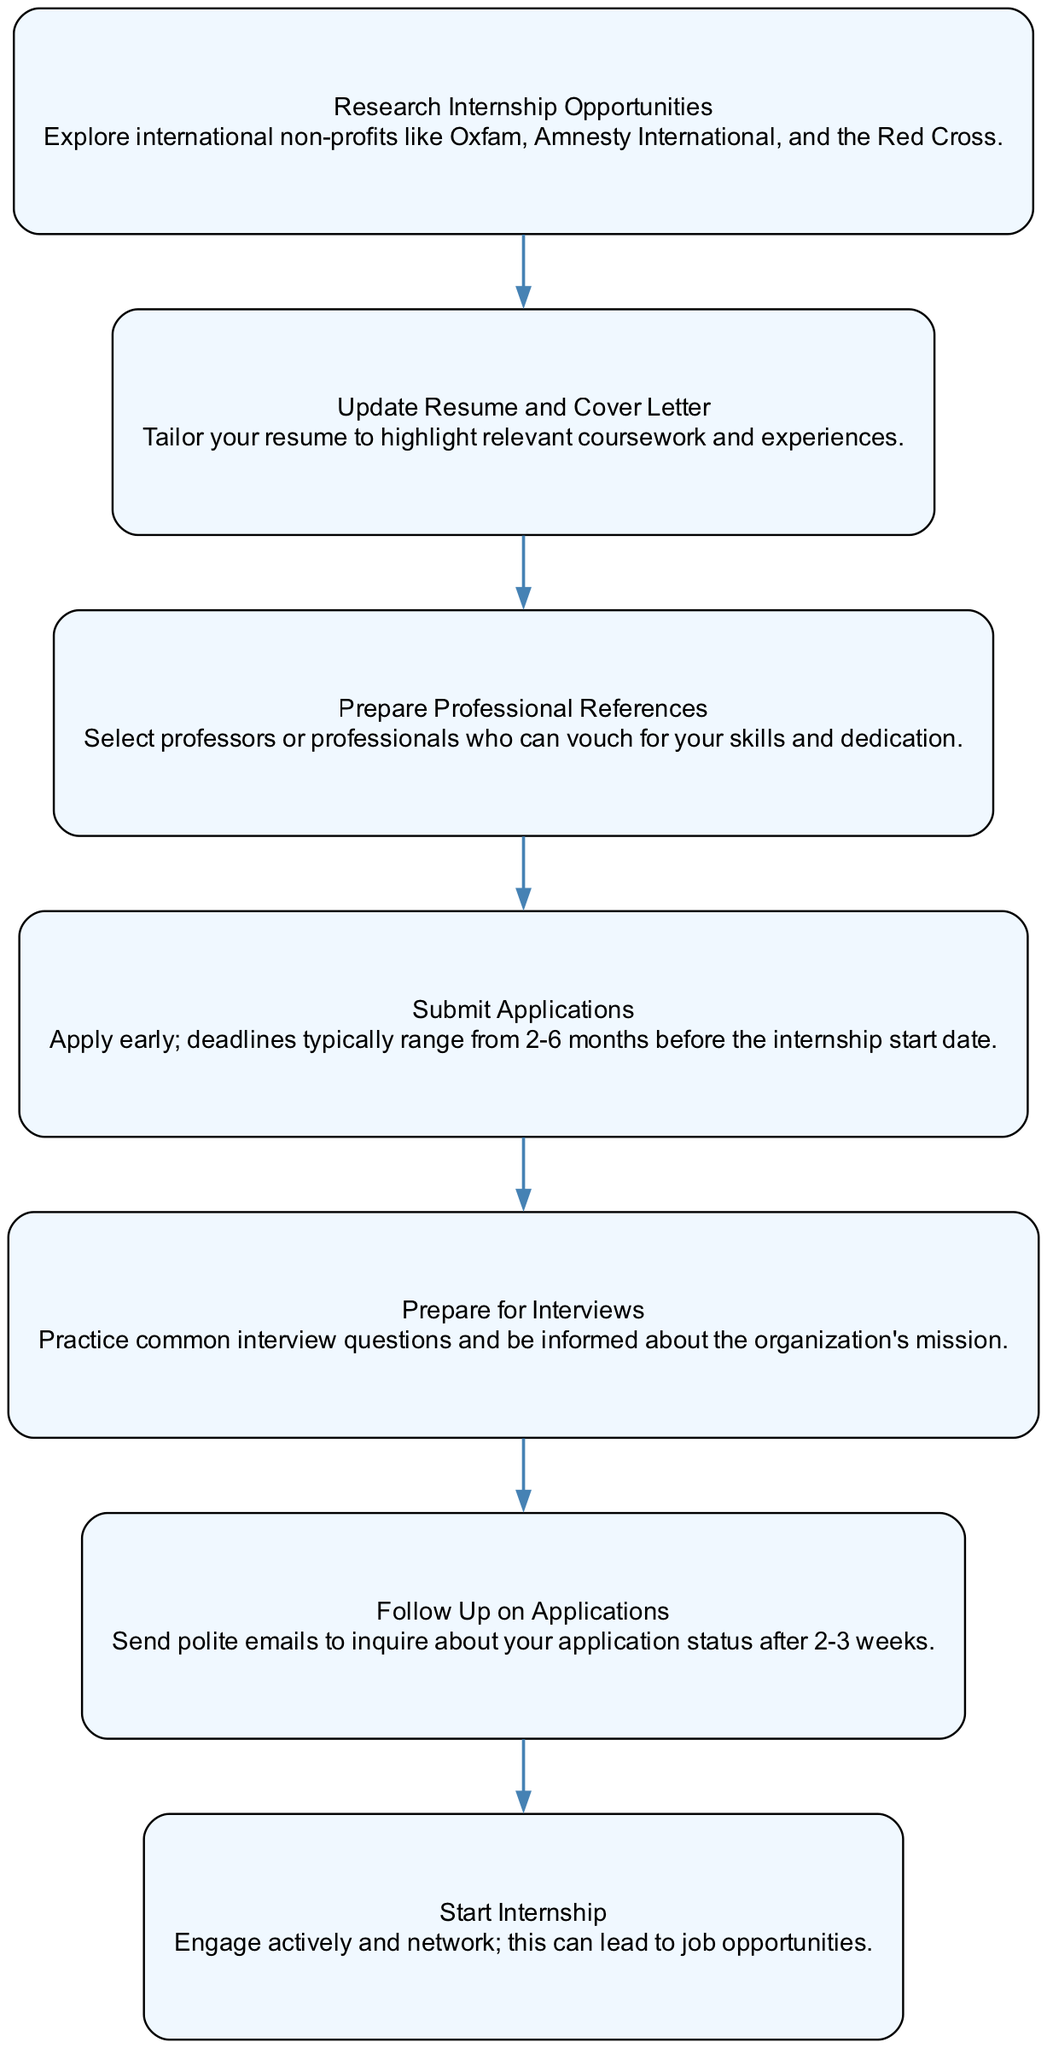What is the first step in applying for internships? The first step shown in the diagram is "Research Internship Opportunities," which involves exploring various international non-profits.
Answer: Research Internship Opportunities How many nodes are present in the diagram? By counting the nodes listed in the data, there are a total of 7 distinct nodes representing different steps in the internship application process.
Answer: 7 What node comes after "Prepare References"? According to the diagram, "Submit Applications" follows the "Prepare Professional References" step.
Answer: Submit Applications Which node indicates a need for immediate action after submitting applications? The next node after "Submit Applications" is "Prepare for Interviews," indicating that preparation for interviews should happen promptly after submitting applications.
Answer: Prepare for Interviews What is the connection between "Follow Up" and "Internship Start"? The relationship depicted in the diagram shows that "Follow Up on Applications" is a step that directly leads to "Start Internship," suggesting that following up is critical to beginning the internship.
Answer: Follow Up on Applications If you complete "Interview Preparation," what should you expect next? After completing the "Prepare for Interviews" step, the next expectation should be "Follow Up on Applications" as shown in the progression of the diagram.
Answer: Follow Up on Applications What is the action recommended about references? The diagram suggests "Prepare Professional References," indicating that selecting and getting references ready is a prerequisite step in the application process.
Answer: Prepare Professional References What color is used for the nodes in the diagram? The color specified in the diagram for the nodes is a light blue shade identified as '#F0F8FF.'
Answer: Light blue Which step shows the importance of networking? The final step, "Start Internship," emphasizes engaging actively and networking, indicating its significance in potentially leading to job opportunities.
Answer: Start Internship 